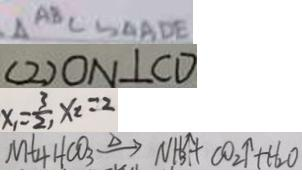Convert formula to latex. <formula><loc_0><loc_0><loc_500><loc_500>\Delta A B C \sim \Delta A D E 
 ( 2 ) O N \bot C D 
 x _ { 1 } = \frac { 3 } { 2 } , x _ { 2 } = 2 
 M t _ { 4 } H C O _ { 3 } \xrightarrow { \Delta } N H _ { 3 } \uparrow + C O _ { 2 } \uparrow + H _ { 2 } O</formula> 